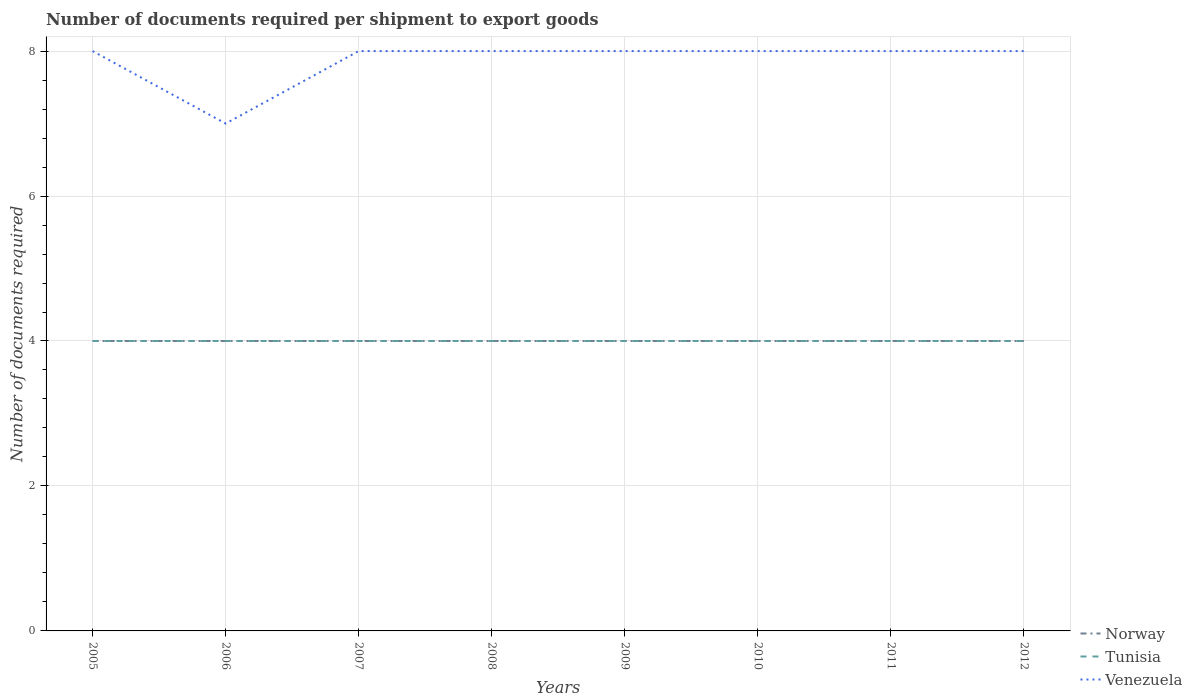Does the line corresponding to Venezuela intersect with the line corresponding to Tunisia?
Ensure brevity in your answer.  No. Across all years, what is the maximum number of documents required per shipment to export goods in Norway?
Provide a succinct answer. 4. In which year was the number of documents required per shipment to export goods in Norway maximum?
Offer a terse response. 2005. What is the total number of documents required per shipment to export goods in Venezuela in the graph?
Offer a terse response. 0. What is the difference between the highest and the second highest number of documents required per shipment to export goods in Venezuela?
Ensure brevity in your answer.  1. Is the number of documents required per shipment to export goods in Norway strictly greater than the number of documents required per shipment to export goods in Tunisia over the years?
Provide a short and direct response. No. How many lines are there?
Offer a terse response. 3. Are the values on the major ticks of Y-axis written in scientific E-notation?
Provide a succinct answer. No. Does the graph contain any zero values?
Provide a short and direct response. No. How many legend labels are there?
Keep it short and to the point. 3. What is the title of the graph?
Your answer should be very brief. Number of documents required per shipment to export goods. What is the label or title of the Y-axis?
Your answer should be very brief. Number of documents required. What is the Number of documents required in Tunisia in 2006?
Provide a short and direct response. 4. What is the Number of documents required in Tunisia in 2007?
Ensure brevity in your answer.  4. What is the Number of documents required of Tunisia in 2008?
Give a very brief answer. 4. What is the Number of documents required in Tunisia in 2009?
Your answer should be very brief. 4. What is the Number of documents required of Venezuela in 2009?
Provide a short and direct response. 8. What is the Number of documents required in Tunisia in 2010?
Provide a succinct answer. 4. What is the Number of documents required of Venezuela in 2010?
Offer a very short reply. 8. What is the Number of documents required of Norway in 2011?
Make the answer very short. 4. What is the Number of documents required of Tunisia in 2011?
Offer a terse response. 4. What is the Number of documents required in Norway in 2012?
Offer a terse response. 4. What is the Number of documents required of Tunisia in 2012?
Provide a short and direct response. 4. What is the Number of documents required of Venezuela in 2012?
Your answer should be very brief. 8. Across all years, what is the maximum Number of documents required in Norway?
Offer a terse response. 4. What is the total Number of documents required in Norway in the graph?
Ensure brevity in your answer.  32. What is the difference between the Number of documents required of Norway in 2005 and that in 2006?
Give a very brief answer. 0. What is the difference between the Number of documents required in Tunisia in 2005 and that in 2006?
Make the answer very short. 0. What is the difference between the Number of documents required of Norway in 2005 and that in 2007?
Your answer should be very brief. 0. What is the difference between the Number of documents required in Tunisia in 2005 and that in 2007?
Provide a short and direct response. 0. What is the difference between the Number of documents required of Norway in 2005 and that in 2008?
Provide a short and direct response. 0. What is the difference between the Number of documents required of Tunisia in 2005 and that in 2008?
Your answer should be compact. 0. What is the difference between the Number of documents required in Venezuela in 2005 and that in 2008?
Make the answer very short. 0. What is the difference between the Number of documents required in Tunisia in 2005 and that in 2009?
Make the answer very short. 0. What is the difference between the Number of documents required of Venezuela in 2005 and that in 2009?
Ensure brevity in your answer.  0. What is the difference between the Number of documents required of Norway in 2005 and that in 2010?
Your answer should be compact. 0. What is the difference between the Number of documents required of Tunisia in 2005 and that in 2010?
Make the answer very short. 0. What is the difference between the Number of documents required of Norway in 2005 and that in 2011?
Your response must be concise. 0. What is the difference between the Number of documents required in Venezuela in 2005 and that in 2012?
Provide a short and direct response. 0. What is the difference between the Number of documents required of Tunisia in 2006 and that in 2007?
Keep it short and to the point. 0. What is the difference between the Number of documents required in Tunisia in 2006 and that in 2008?
Your response must be concise. 0. What is the difference between the Number of documents required in Venezuela in 2006 and that in 2008?
Make the answer very short. -1. What is the difference between the Number of documents required in Tunisia in 2006 and that in 2009?
Offer a terse response. 0. What is the difference between the Number of documents required in Norway in 2006 and that in 2010?
Give a very brief answer. 0. What is the difference between the Number of documents required of Venezuela in 2006 and that in 2010?
Provide a short and direct response. -1. What is the difference between the Number of documents required in Tunisia in 2006 and that in 2011?
Your answer should be compact. 0. What is the difference between the Number of documents required of Norway in 2006 and that in 2012?
Make the answer very short. 0. What is the difference between the Number of documents required in Tunisia in 2006 and that in 2012?
Your answer should be very brief. 0. What is the difference between the Number of documents required of Venezuela in 2007 and that in 2008?
Your answer should be very brief. 0. What is the difference between the Number of documents required of Venezuela in 2007 and that in 2009?
Your answer should be compact. 0. What is the difference between the Number of documents required in Tunisia in 2007 and that in 2010?
Your answer should be very brief. 0. What is the difference between the Number of documents required in Tunisia in 2007 and that in 2011?
Your answer should be compact. 0. What is the difference between the Number of documents required in Norway in 2008 and that in 2009?
Your response must be concise. 0. What is the difference between the Number of documents required of Norway in 2008 and that in 2011?
Offer a terse response. 0. What is the difference between the Number of documents required of Tunisia in 2008 and that in 2011?
Your response must be concise. 0. What is the difference between the Number of documents required in Norway in 2008 and that in 2012?
Provide a succinct answer. 0. What is the difference between the Number of documents required of Venezuela in 2008 and that in 2012?
Your answer should be very brief. 0. What is the difference between the Number of documents required in Norway in 2009 and that in 2010?
Ensure brevity in your answer.  0. What is the difference between the Number of documents required in Venezuela in 2009 and that in 2010?
Provide a short and direct response. 0. What is the difference between the Number of documents required in Norway in 2009 and that in 2012?
Offer a very short reply. 0. What is the difference between the Number of documents required of Tunisia in 2009 and that in 2012?
Your response must be concise. 0. What is the difference between the Number of documents required of Norway in 2010 and that in 2012?
Your answer should be very brief. 0. What is the difference between the Number of documents required of Tunisia in 2010 and that in 2012?
Give a very brief answer. 0. What is the difference between the Number of documents required in Venezuela in 2010 and that in 2012?
Make the answer very short. 0. What is the difference between the Number of documents required of Tunisia in 2011 and that in 2012?
Ensure brevity in your answer.  0. What is the difference between the Number of documents required in Norway in 2005 and the Number of documents required in Tunisia in 2006?
Provide a short and direct response. 0. What is the difference between the Number of documents required of Norway in 2005 and the Number of documents required of Venezuela in 2006?
Ensure brevity in your answer.  -3. What is the difference between the Number of documents required of Norway in 2005 and the Number of documents required of Venezuela in 2008?
Your answer should be compact. -4. What is the difference between the Number of documents required in Norway in 2005 and the Number of documents required in Tunisia in 2009?
Your answer should be compact. 0. What is the difference between the Number of documents required in Norway in 2005 and the Number of documents required in Venezuela in 2009?
Your response must be concise. -4. What is the difference between the Number of documents required in Norway in 2005 and the Number of documents required in Tunisia in 2010?
Your answer should be very brief. 0. What is the difference between the Number of documents required of Norway in 2005 and the Number of documents required of Venezuela in 2010?
Give a very brief answer. -4. What is the difference between the Number of documents required of Tunisia in 2005 and the Number of documents required of Venezuela in 2010?
Make the answer very short. -4. What is the difference between the Number of documents required of Norway in 2006 and the Number of documents required of Tunisia in 2007?
Provide a short and direct response. 0. What is the difference between the Number of documents required of Tunisia in 2006 and the Number of documents required of Venezuela in 2007?
Your answer should be very brief. -4. What is the difference between the Number of documents required in Norway in 2006 and the Number of documents required in Tunisia in 2008?
Ensure brevity in your answer.  0. What is the difference between the Number of documents required of Norway in 2006 and the Number of documents required of Tunisia in 2009?
Provide a succinct answer. 0. What is the difference between the Number of documents required in Norway in 2006 and the Number of documents required in Venezuela in 2009?
Your answer should be compact. -4. What is the difference between the Number of documents required of Tunisia in 2006 and the Number of documents required of Venezuela in 2009?
Your response must be concise. -4. What is the difference between the Number of documents required of Norway in 2006 and the Number of documents required of Tunisia in 2010?
Provide a succinct answer. 0. What is the difference between the Number of documents required in Norway in 2006 and the Number of documents required in Venezuela in 2010?
Your answer should be compact. -4. What is the difference between the Number of documents required of Norway in 2006 and the Number of documents required of Tunisia in 2011?
Your response must be concise. 0. What is the difference between the Number of documents required of Norway in 2006 and the Number of documents required of Venezuela in 2011?
Your answer should be very brief. -4. What is the difference between the Number of documents required in Tunisia in 2006 and the Number of documents required in Venezuela in 2011?
Ensure brevity in your answer.  -4. What is the difference between the Number of documents required in Norway in 2006 and the Number of documents required in Tunisia in 2012?
Your answer should be very brief. 0. What is the difference between the Number of documents required of Norway in 2006 and the Number of documents required of Venezuela in 2012?
Offer a terse response. -4. What is the difference between the Number of documents required of Tunisia in 2006 and the Number of documents required of Venezuela in 2012?
Provide a short and direct response. -4. What is the difference between the Number of documents required in Norway in 2007 and the Number of documents required in Tunisia in 2008?
Provide a succinct answer. 0. What is the difference between the Number of documents required of Tunisia in 2007 and the Number of documents required of Venezuela in 2008?
Offer a very short reply. -4. What is the difference between the Number of documents required in Norway in 2007 and the Number of documents required in Tunisia in 2009?
Your response must be concise. 0. What is the difference between the Number of documents required of Norway in 2007 and the Number of documents required of Venezuela in 2009?
Give a very brief answer. -4. What is the difference between the Number of documents required in Tunisia in 2007 and the Number of documents required in Venezuela in 2009?
Make the answer very short. -4. What is the difference between the Number of documents required in Norway in 2007 and the Number of documents required in Tunisia in 2010?
Your response must be concise. 0. What is the difference between the Number of documents required of Tunisia in 2007 and the Number of documents required of Venezuela in 2010?
Provide a short and direct response. -4. What is the difference between the Number of documents required in Norway in 2007 and the Number of documents required in Tunisia in 2011?
Offer a very short reply. 0. What is the difference between the Number of documents required of Norway in 2007 and the Number of documents required of Venezuela in 2011?
Provide a succinct answer. -4. What is the difference between the Number of documents required of Norway in 2007 and the Number of documents required of Tunisia in 2012?
Ensure brevity in your answer.  0. What is the difference between the Number of documents required in Norway in 2007 and the Number of documents required in Venezuela in 2012?
Offer a terse response. -4. What is the difference between the Number of documents required of Tunisia in 2007 and the Number of documents required of Venezuela in 2012?
Your response must be concise. -4. What is the difference between the Number of documents required of Norway in 2008 and the Number of documents required of Tunisia in 2009?
Provide a succinct answer. 0. What is the difference between the Number of documents required in Tunisia in 2008 and the Number of documents required in Venezuela in 2010?
Provide a short and direct response. -4. What is the difference between the Number of documents required in Norway in 2008 and the Number of documents required in Venezuela in 2011?
Ensure brevity in your answer.  -4. What is the difference between the Number of documents required of Norway in 2008 and the Number of documents required of Venezuela in 2012?
Ensure brevity in your answer.  -4. What is the difference between the Number of documents required of Tunisia in 2008 and the Number of documents required of Venezuela in 2012?
Offer a terse response. -4. What is the difference between the Number of documents required in Tunisia in 2009 and the Number of documents required in Venezuela in 2010?
Your answer should be very brief. -4. What is the difference between the Number of documents required of Norway in 2009 and the Number of documents required of Tunisia in 2011?
Keep it short and to the point. 0. What is the difference between the Number of documents required in Norway in 2009 and the Number of documents required in Venezuela in 2011?
Keep it short and to the point. -4. What is the difference between the Number of documents required of Tunisia in 2009 and the Number of documents required of Venezuela in 2012?
Provide a short and direct response. -4. What is the difference between the Number of documents required of Norway in 2010 and the Number of documents required of Tunisia in 2011?
Your response must be concise. 0. What is the difference between the Number of documents required in Norway in 2010 and the Number of documents required in Venezuela in 2011?
Offer a very short reply. -4. What is the difference between the Number of documents required of Tunisia in 2010 and the Number of documents required of Venezuela in 2011?
Give a very brief answer. -4. What is the difference between the Number of documents required of Norway in 2010 and the Number of documents required of Tunisia in 2012?
Give a very brief answer. 0. What is the difference between the Number of documents required in Norway in 2010 and the Number of documents required in Venezuela in 2012?
Give a very brief answer. -4. What is the difference between the Number of documents required in Tunisia in 2011 and the Number of documents required in Venezuela in 2012?
Your answer should be very brief. -4. What is the average Number of documents required of Norway per year?
Provide a short and direct response. 4. What is the average Number of documents required of Venezuela per year?
Offer a very short reply. 7.88. In the year 2005, what is the difference between the Number of documents required in Norway and Number of documents required in Tunisia?
Keep it short and to the point. 0. In the year 2005, what is the difference between the Number of documents required of Tunisia and Number of documents required of Venezuela?
Keep it short and to the point. -4. In the year 2006, what is the difference between the Number of documents required in Norway and Number of documents required in Tunisia?
Your answer should be very brief. 0. In the year 2006, what is the difference between the Number of documents required in Tunisia and Number of documents required in Venezuela?
Offer a terse response. -3. In the year 2007, what is the difference between the Number of documents required in Norway and Number of documents required in Tunisia?
Offer a terse response. 0. In the year 2007, what is the difference between the Number of documents required in Norway and Number of documents required in Venezuela?
Your answer should be compact. -4. In the year 2009, what is the difference between the Number of documents required of Tunisia and Number of documents required of Venezuela?
Offer a very short reply. -4. In the year 2011, what is the difference between the Number of documents required of Norway and Number of documents required of Tunisia?
Provide a short and direct response. 0. In the year 2011, what is the difference between the Number of documents required in Norway and Number of documents required in Venezuela?
Your answer should be very brief. -4. In the year 2011, what is the difference between the Number of documents required in Tunisia and Number of documents required in Venezuela?
Provide a short and direct response. -4. In the year 2012, what is the difference between the Number of documents required in Tunisia and Number of documents required in Venezuela?
Ensure brevity in your answer.  -4. What is the ratio of the Number of documents required in Tunisia in 2005 to that in 2006?
Ensure brevity in your answer.  1. What is the ratio of the Number of documents required in Venezuela in 2005 to that in 2006?
Give a very brief answer. 1.14. What is the ratio of the Number of documents required of Norway in 2005 to that in 2007?
Your response must be concise. 1. What is the ratio of the Number of documents required in Venezuela in 2005 to that in 2007?
Make the answer very short. 1. What is the ratio of the Number of documents required in Norway in 2005 to that in 2008?
Your response must be concise. 1. What is the ratio of the Number of documents required of Tunisia in 2005 to that in 2008?
Your answer should be very brief. 1. What is the ratio of the Number of documents required of Tunisia in 2005 to that in 2009?
Provide a succinct answer. 1. What is the ratio of the Number of documents required of Venezuela in 2005 to that in 2009?
Make the answer very short. 1. What is the ratio of the Number of documents required of Tunisia in 2005 to that in 2010?
Your response must be concise. 1. What is the ratio of the Number of documents required in Venezuela in 2005 to that in 2010?
Give a very brief answer. 1. What is the ratio of the Number of documents required in Norway in 2005 to that in 2011?
Keep it short and to the point. 1. What is the ratio of the Number of documents required of Tunisia in 2005 to that in 2011?
Provide a short and direct response. 1. What is the ratio of the Number of documents required of Venezuela in 2005 to that in 2011?
Give a very brief answer. 1. What is the ratio of the Number of documents required of Norway in 2005 to that in 2012?
Your response must be concise. 1. What is the ratio of the Number of documents required of Venezuela in 2005 to that in 2012?
Make the answer very short. 1. What is the ratio of the Number of documents required in Tunisia in 2006 to that in 2007?
Provide a succinct answer. 1. What is the ratio of the Number of documents required of Tunisia in 2006 to that in 2009?
Provide a short and direct response. 1. What is the ratio of the Number of documents required of Tunisia in 2006 to that in 2010?
Your answer should be compact. 1. What is the ratio of the Number of documents required in Tunisia in 2006 to that in 2011?
Your answer should be very brief. 1. What is the ratio of the Number of documents required of Norway in 2006 to that in 2012?
Your response must be concise. 1. What is the ratio of the Number of documents required of Tunisia in 2006 to that in 2012?
Make the answer very short. 1. What is the ratio of the Number of documents required of Norway in 2007 to that in 2008?
Ensure brevity in your answer.  1. What is the ratio of the Number of documents required of Norway in 2007 to that in 2010?
Keep it short and to the point. 1. What is the ratio of the Number of documents required in Tunisia in 2007 to that in 2011?
Provide a short and direct response. 1. What is the ratio of the Number of documents required in Venezuela in 2007 to that in 2011?
Ensure brevity in your answer.  1. What is the ratio of the Number of documents required of Tunisia in 2007 to that in 2012?
Give a very brief answer. 1. What is the ratio of the Number of documents required of Tunisia in 2008 to that in 2009?
Your answer should be very brief. 1. What is the ratio of the Number of documents required of Venezuela in 2008 to that in 2009?
Offer a terse response. 1. What is the ratio of the Number of documents required of Tunisia in 2008 to that in 2010?
Your answer should be compact. 1. What is the ratio of the Number of documents required of Venezuela in 2008 to that in 2010?
Your response must be concise. 1. What is the ratio of the Number of documents required in Norway in 2009 to that in 2010?
Provide a short and direct response. 1. What is the ratio of the Number of documents required of Tunisia in 2009 to that in 2010?
Ensure brevity in your answer.  1. What is the ratio of the Number of documents required in Tunisia in 2009 to that in 2011?
Ensure brevity in your answer.  1. What is the ratio of the Number of documents required in Venezuela in 2009 to that in 2011?
Give a very brief answer. 1. What is the ratio of the Number of documents required in Norway in 2009 to that in 2012?
Your response must be concise. 1. What is the ratio of the Number of documents required of Venezuela in 2009 to that in 2012?
Provide a succinct answer. 1. What is the ratio of the Number of documents required in Tunisia in 2010 to that in 2012?
Offer a terse response. 1. What is the difference between the highest and the second highest Number of documents required in Tunisia?
Offer a terse response. 0. What is the difference between the highest and the second highest Number of documents required of Venezuela?
Your answer should be very brief. 0. What is the difference between the highest and the lowest Number of documents required of Norway?
Give a very brief answer. 0. What is the difference between the highest and the lowest Number of documents required of Tunisia?
Provide a succinct answer. 0. What is the difference between the highest and the lowest Number of documents required in Venezuela?
Provide a succinct answer. 1. 